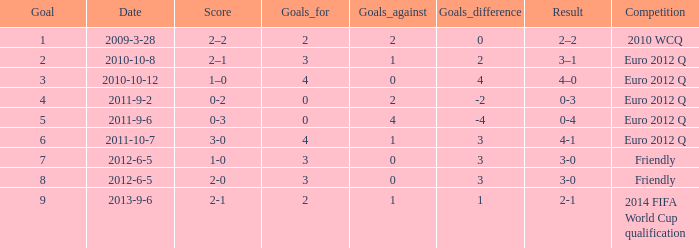What is the result when the score is 0-2? 0-3. 